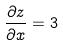<formula> <loc_0><loc_0><loc_500><loc_500>\frac { \partial z } { \partial x } = 3</formula> 